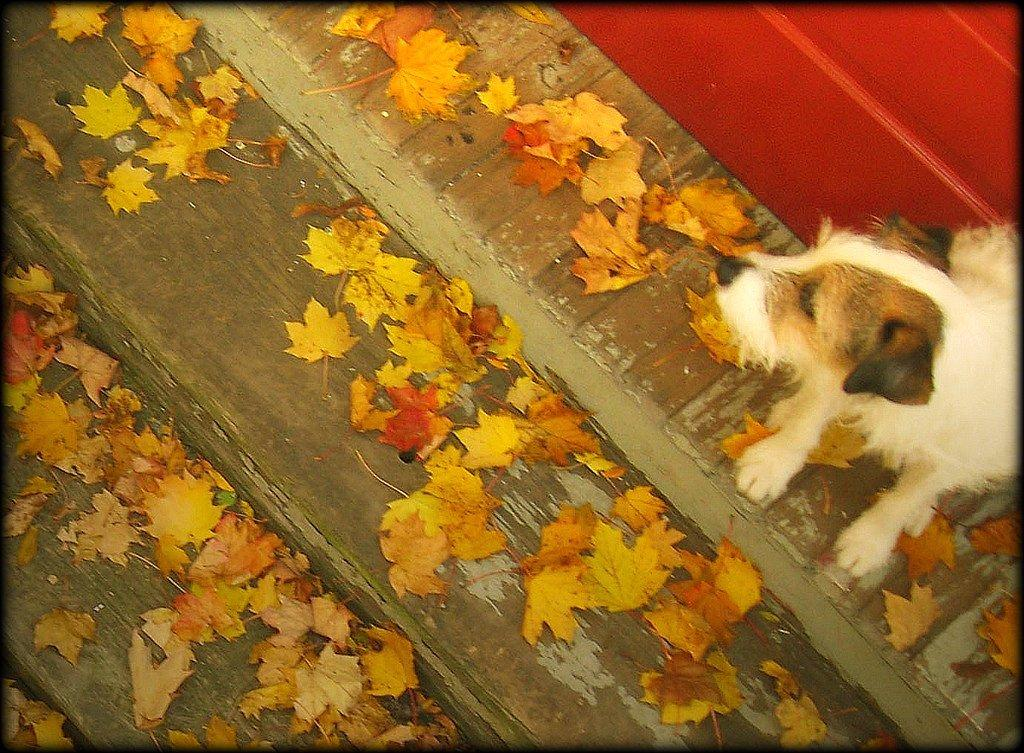What is on the floor in the image? There are dried leaves on the floor in the image. What type of animal can be seen in the image? There is a dog in the image. What can be seen in the top right corner of the image? There appears to be a wall in the top right corner of the image. Where is the scarecrow located in the image? There is no scarecrow present in the image. What color is the rail in the image? There is no rail present in the image. 